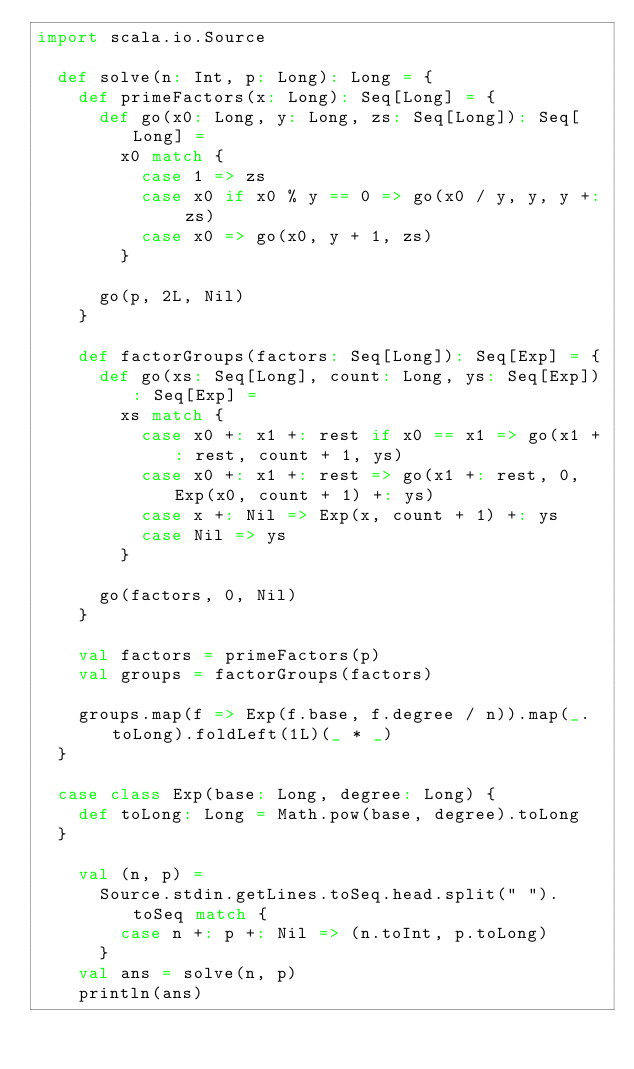Convert code to text. <code><loc_0><loc_0><loc_500><loc_500><_Scala_>import scala.io.Source

  def solve(n: Int, p: Long): Long = {
    def primeFactors(x: Long): Seq[Long] = {
      def go(x0: Long, y: Long, zs: Seq[Long]): Seq[Long] =
        x0 match {
          case 1 => zs
          case x0 if x0 % y == 0 => go(x0 / y, y, y +: zs)
          case x0 => go(x0, y + 1, zs)
        }

      go(p, 2L, Nil)
    }

    def factorGroups(factors: Seq[Long]): Seq[Exp] = {
      def go(xs: Seq[Long], count: Long, ys: Seq[Exp]): Seq[Exp] =
        xs match {
          case x0 +: x1 +: rest if x0 == x1 => go(x1 +: rest, count + 1, ys)
          case x0 +: x1 +: rest => go(x1 +: rest, 0, Exp(x0, count + 1) +: ys)
          case x +: Nil => Exp(x, count + 1) +: ys
          case Nil => ys
        }

      go(factors, 0, Nil)
    }

    val factors = primeFactors(p)
    val groups = factorGroups(factors)

    groups.map(f => Exp(f.base, f.degree / n)).map(_.toLong).foldLeft(1L)(_ * _)
  }

  case class Exp(base: Long, degree: Long) {
    def toLong: Long = Math.pow(base, degree).toLong
  }

    val (n, p) =
      Source.stdin.getLines.toSeq.head.split(" ").toSeq match {
        case n +: p +: Nil => (n.toInt, p.toLong)
      }
    val ans = solve(n, p)
    println(ans)
</code> 